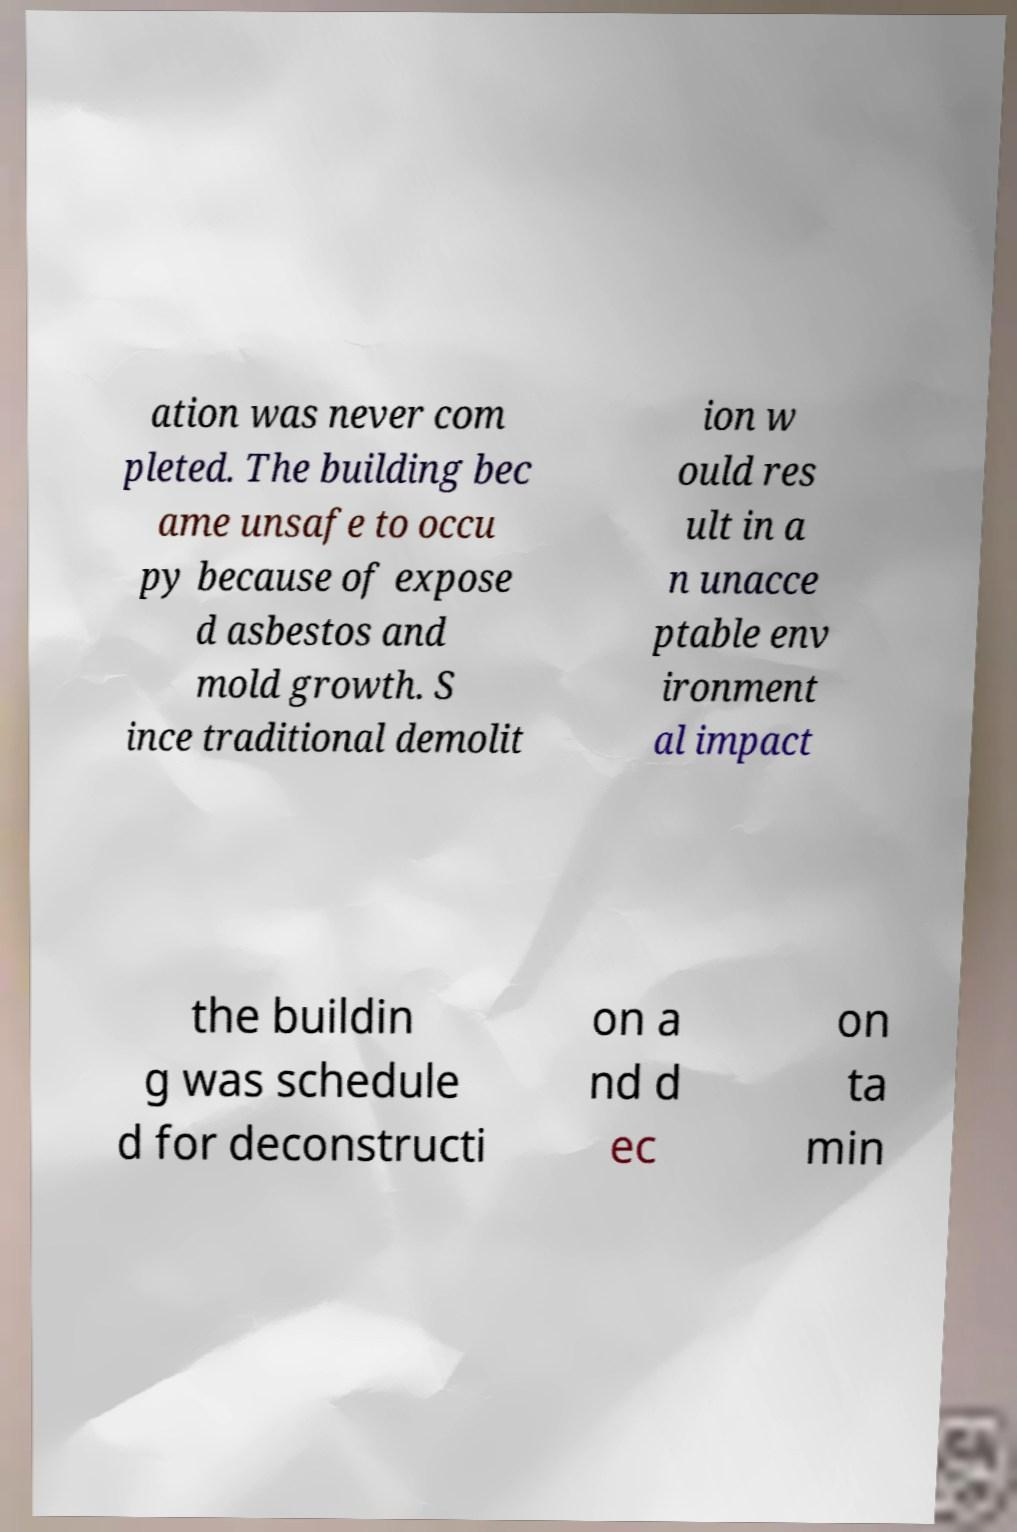Please identify and transcribe the text found in this image. ation was never com pleted. The building bec ame unsafe to occu py because of expose d asbestos and mold growth. S ince traditional demolit ion w ould res ult in a n unacce ptable env ironment al impact the buildin g was schedule d for deconstructi on a nd d ec on ta min 